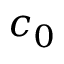<formula> <loc_0><loc_0><loc_500><loc_500>c _ { 0 }</formula> 